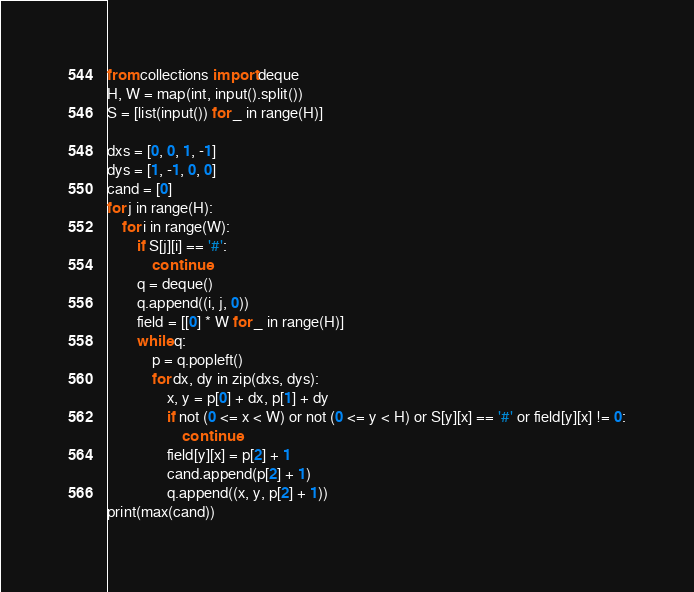Convert code to text. <code><loc_0><loc_0><loc_500><loc_500><_Python_>from collections import deque
H, W = map(int, input().split())
S = [list(input()) for _ in range(H)]

dxs = [0, 0, 1, -1]
dys = [1, -1, 0, 0]
cand = [0]
for j in range(H):
    for i in range(W):
        if S[j][i] == '#':
            continue
        q = deque()
        q.append((i, j, 0))
        field = [[0] * W for _ in range(H)]
        while q:
            p = q.popleft()
            for dx, dy in zip(dxs, dys):
                x, y = p[0] + dx, p[1] + dy
                if not (0 <= x < W) or not (0 <= y < H) or S[y][x] == '#' or field[y][x] != 0:
                    continue
                field[y][x] = p[2] + 1
                cand.append(p[2] + 1)
                q.append((x, y, p[2] + 1))
print(max(cand))</code> 